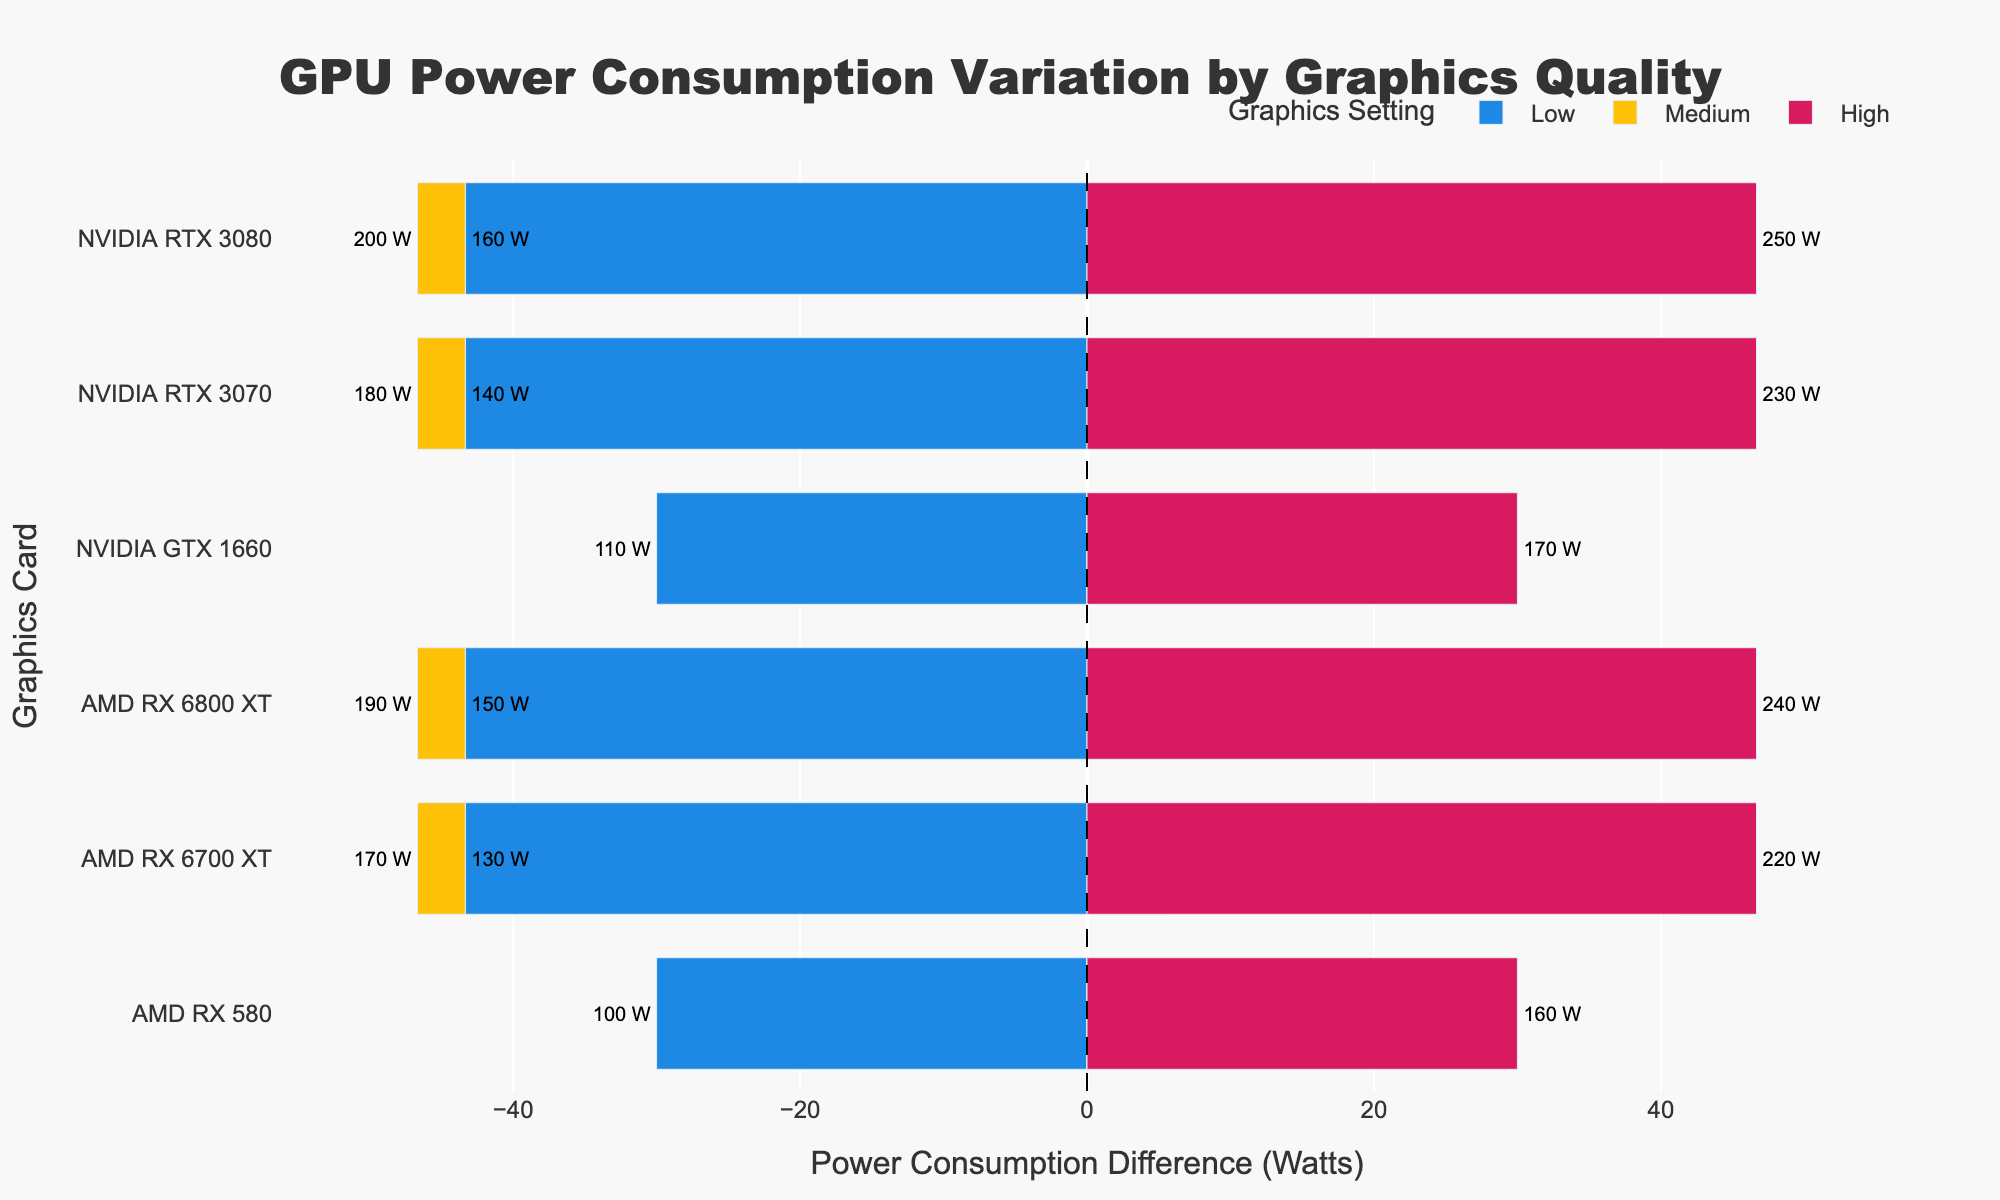What is the range of power consumption for the NVIDIA RTX 3080? The highest power consumption for NVIDIA RTX 3080 is 250 Watts (High setting), and the lowest is 160 Watts (Low setting). So, the range is the difference between these values: 250 - 160 = 90 Watts.
Answer: 90 Watts Which GPU has the highest power consumption at the medium setting? By examining the bars at the Medium setting (yellow), the NVIDIA RTX 3080 has the highest power consumption with 200 Watts.
Answer: NVIDIA RTX 3080 What is the average power consumption difference for AMD RX 6700 XT across all settings? First, find the power consumption differences for AMD RX 6700 XT in each setting: Low (-15), Medium (25), and High (75). To get the average, sum these differences and divide by the number of settings: (-15 + 25 + 75)/3 = 85/3 ≈ 28.3 Watts.
Answer: 28.3 Watts How does the power consumption of NVIDIA GTX 1660 at high compare to the AMD RX 580 at the same setting? The NVIDIA GTX 1660 at High setting consumes 170 Watts, while the AMD RX 580 at High setting consumes 160 Watts. So, the NVIDIA GTX 1660 consumes 10 Watts more than the AMD RX 580 at High setting.
Answer: 10 Watts more What is the total power consumption for the NVIDIA RTX 3070 across all settings? Add the power consumption values for all settings of NVIDIA RTX 3070: 140 (Low) + 180 (Medium) + 230 (High) = 550 Watts.
Answer: 550 Watts 